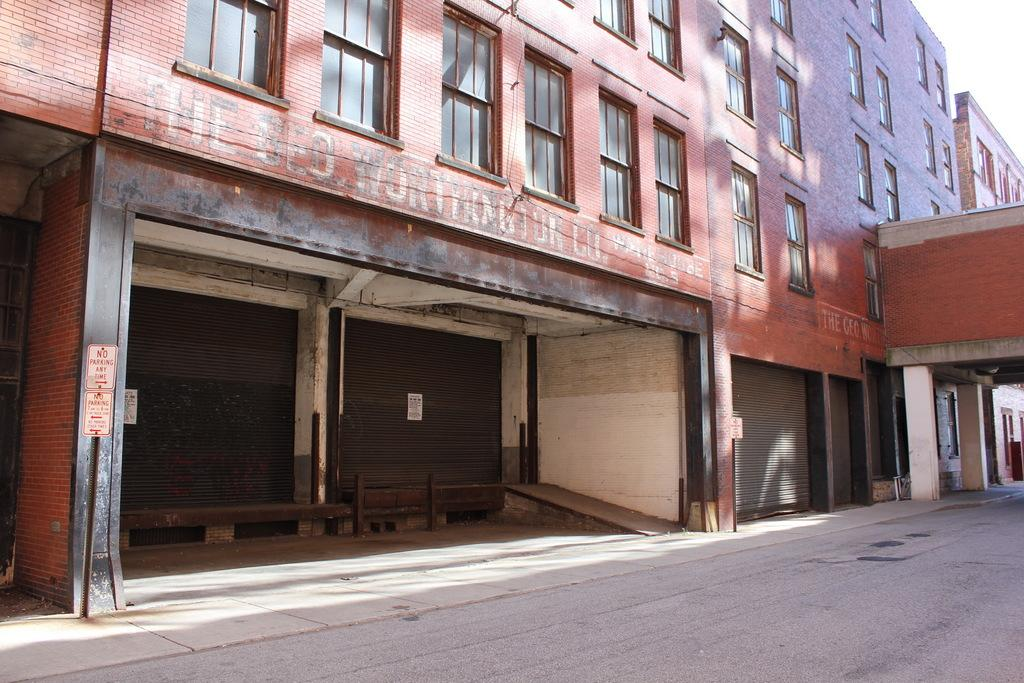What is located at the bottom of the image? There is a road at the bottom of the image. What can be seen in terms of architecture in the image? There are buildings in red color in the image, and they have pillars and windows. Can you describe the shutter in the image? There is a shutter on the right side of the image. How does the image compare to a sheet of paper? The image is not a sheet of paper; it is a visual representation of a scene or objects. 